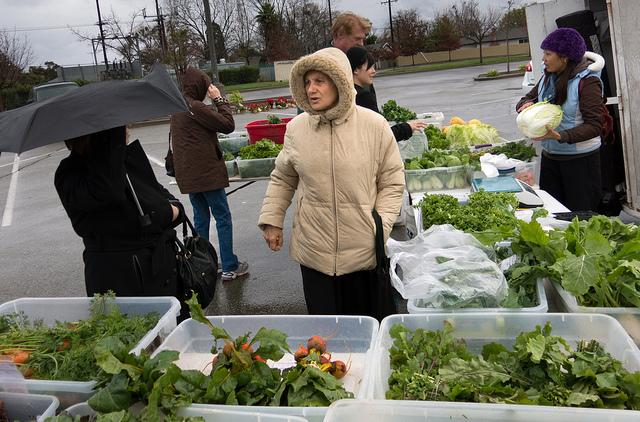What is the woman on the right holding in her hand?

Choices:
A) squash
B) potatoes
C) cabbage
D) watermelon cabbage 